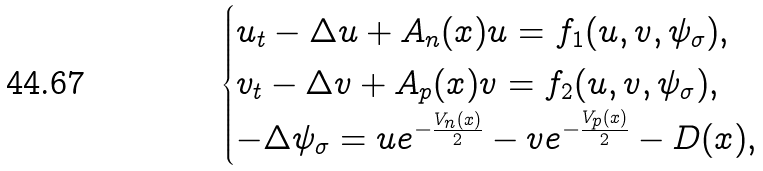Convert formula to latex. <formula><loc_0><loc_0><loc_500><loc_500>\begin{cases} u _ { t } - \Delta u + A _ { n } ( x ) u = f _ { 1 } ( u , v , \psi _ { \sigma } ) , \\ v _ { t } - \Delta v + A _ { p } ( x ) v = f _ { 2 } ( u , v , \psi _ { \sigma } ) , \\ - \Delta \psi _ { \sigma } = u e ^ { - \frac { V _ { n } ( x ) } { 2 } } - v e ^ { - \frac { V _ { p } ( x ) } { 2 } } - D ( x ) , \end{cases}</formula> 